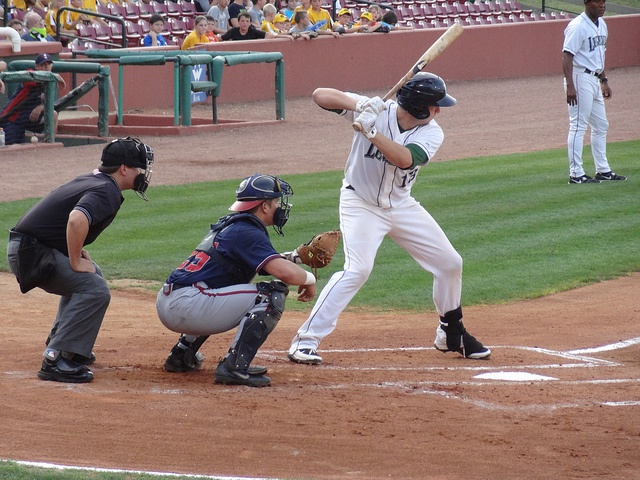Describe the objects in this image and their specific colors. I can see people in darkblue, lavender, darkgray, black, and gray tones, people in darkblue, black, gray, darkgray, and navy tones, people in darkblue, black, gray, and brown tones, people in darkblue, black, darkgray, and gray tones, and people in darkblue, darkgray, and lavender tones in this image. 